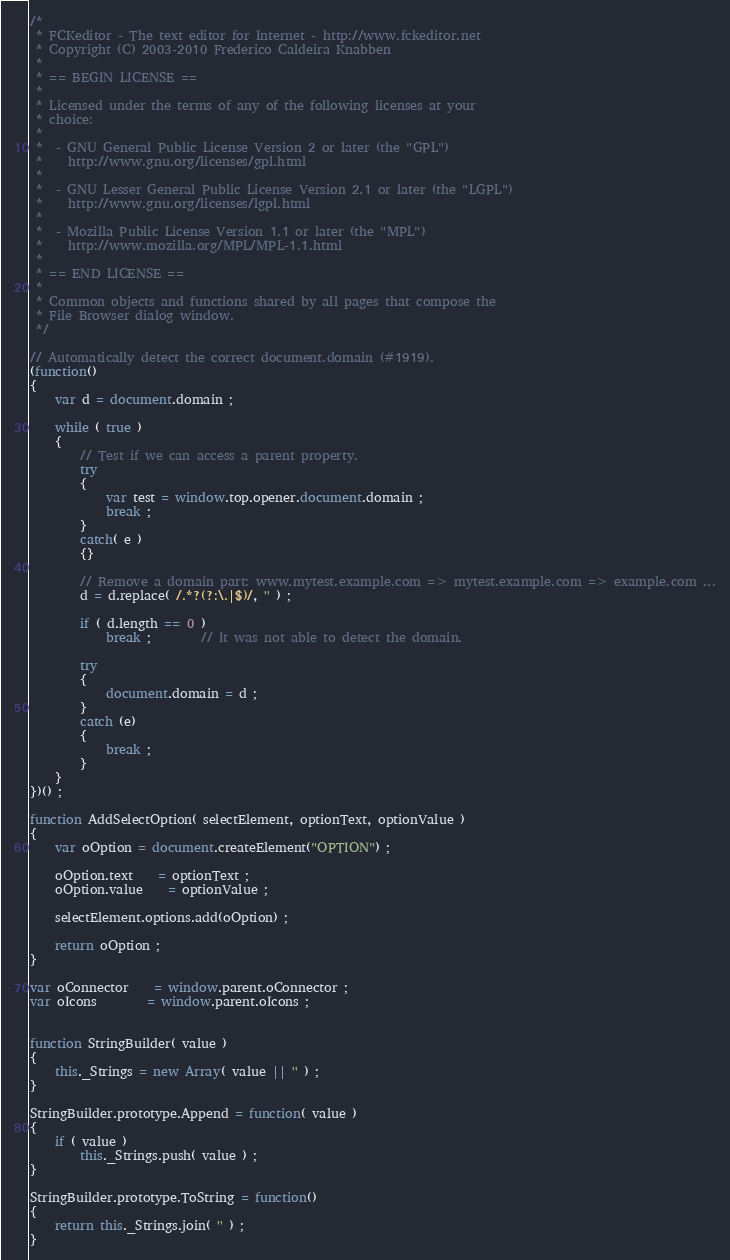<code> <loc_0><loc_0><loc_500><loc_500><_JavaScript_>/*
 * FCKeditor - The text editor for Internet - http://www.fckeditor.net
 * Copyright (C) 2003-2010 Frederico Caldeira Knabben
 *
 * == BEGIN LICENSE ==
 *
 * Licensed under the terms of any of the following licenses at your
 * choice:
 *
 *  - GNU General Public License Version 2 or later (the "GPL")
 *    http://www.gnu.org/licenses/gpl.html
 *
 *  - GNU Lesser General Public License Version 2.1 or later (the "LGPL")
 *    http://www.gnu.org/licenses/lgpl.html
 *
 *  - Mozilla Public License Version 1.1 or later (the "MPL")
 *    http://www.mozilla.org/MPL/MPL-1.1.html
 *
 * == END LICENSE ==
 *
 * Common objects and functions shared by all pages that compose the
 * File Browser dialog window.
 */

// Automatically detect the correct document.domain (#1919).
(function()
{
	var d = document.domain ;

	while ( true )
	{
		// Test if we can access a parent property.
		try
		{
			var test = window.top.opener.document.domain ;
			break ;
		}
		catch( e )
		{}

		// Remove a domain part: www.mytest.example.com => mytest.example.com => example.com ...
		d = d.replace( /.*?(?:\.|$)/, '' ) ;

		if ( d.length == 0 )
			break ;		// It was not able to detect the domain.

		try
		{
			document.domain = d ;
		}
		catch (e)
		{
			break ;
		}
	}
})() ;

function AddSelectOption( selectElement, optionText, optionValue )
{
	var oOption = document.createElement("OPTION") ;

	oOption.text	= optionText ;
	oOption.value	= optionValue ;

	selectElement.options.add(oOption) ;

	return oOption ;
}

var oConnector	= window.parent.oConnector ;
var oIcons		= window.parent.oIcons ;


function StringBuilder( value )
{
    this._Strings = new Array( value || '' ) ;
}

StringBuilder.prototype.Append = function( value )
{
    if ( value )
        this._Strings.push( value ) ;
}

StringBuilder.prototype.ToString = function()
{
    return this._Strings.join( '' ) ;
}
</code> 